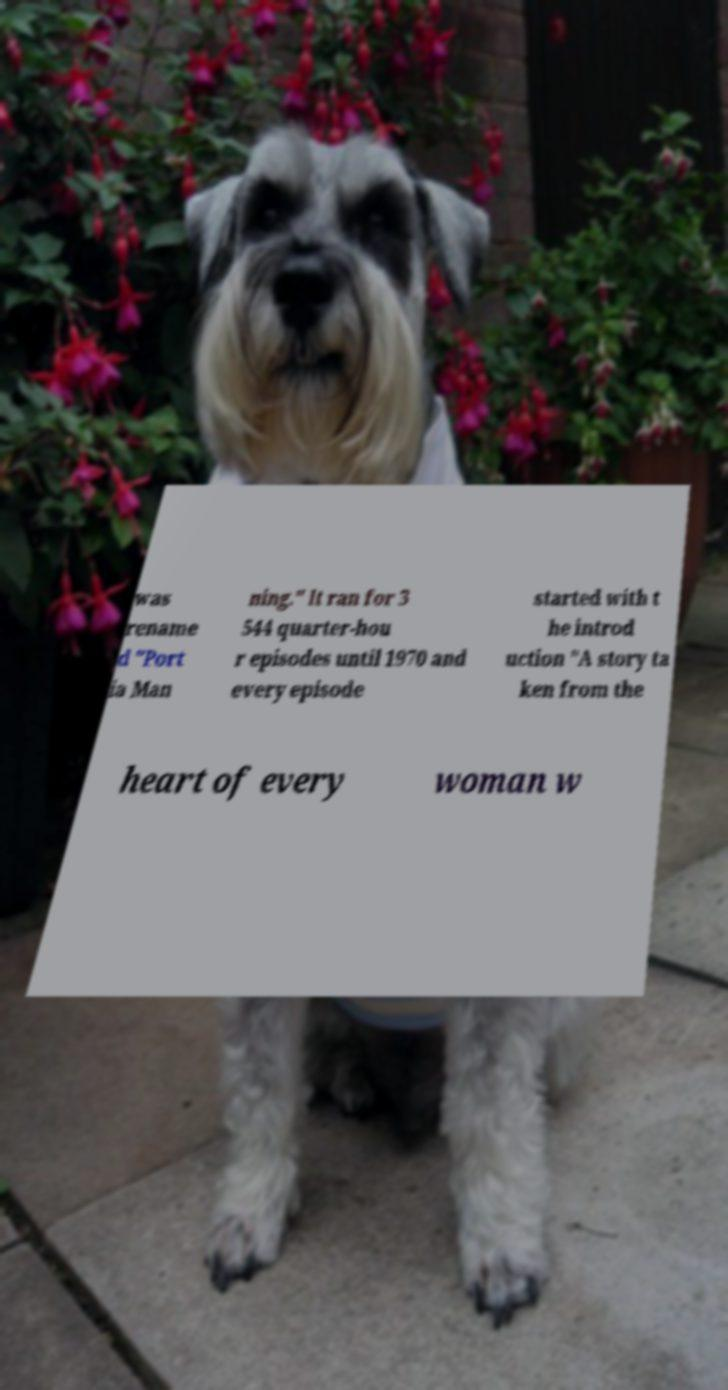Please identify and transcribe the text found in this image. was rename d "Port ia Man ning." It ran for 3 544 quarter-hou r episodes until 1970 and every episode started with t he introd uction "A story ta ken from the heart of every woman w 